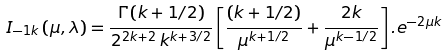<formula> <loc_0><loc_0><loc_500><loc_500>I _ { - 1 k } \left ( \mu , \lambda \right ) = \frac { \Gamma \left ( k + 1 / 2 \right ) } { 2 ^ { 2 k + 2 } \, k ^ { k + 3 / 2 } } \left [ \frac { \left ( k + 1 / 2 \right ) } { \mu ^ { k + 1 / 2 } } + \frac { 2 k } { \mu ^ { k - 1 / 2 } } \right ] . e ^ { - 2 \mu k }</formula> 